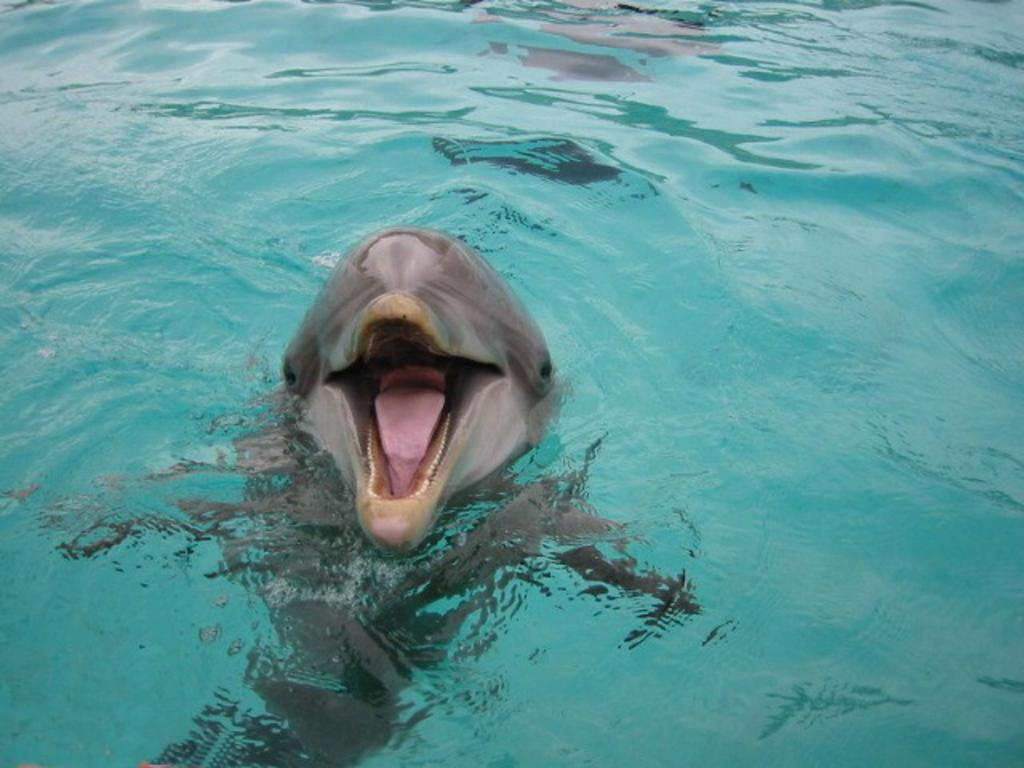What animal is featured in the image? There is a dolphin in the image. Where is the dolphin located? The dolphin is in the water. What type of crime is being committed in the image? There is no crime present in the image; it features a dolphin in the water. Can you tell me where the nearest camp or cemetery is in relation to the image? The provided facts do not mention any camps or cemeteries, so it is not possible to determine their locations in relation to the image. 